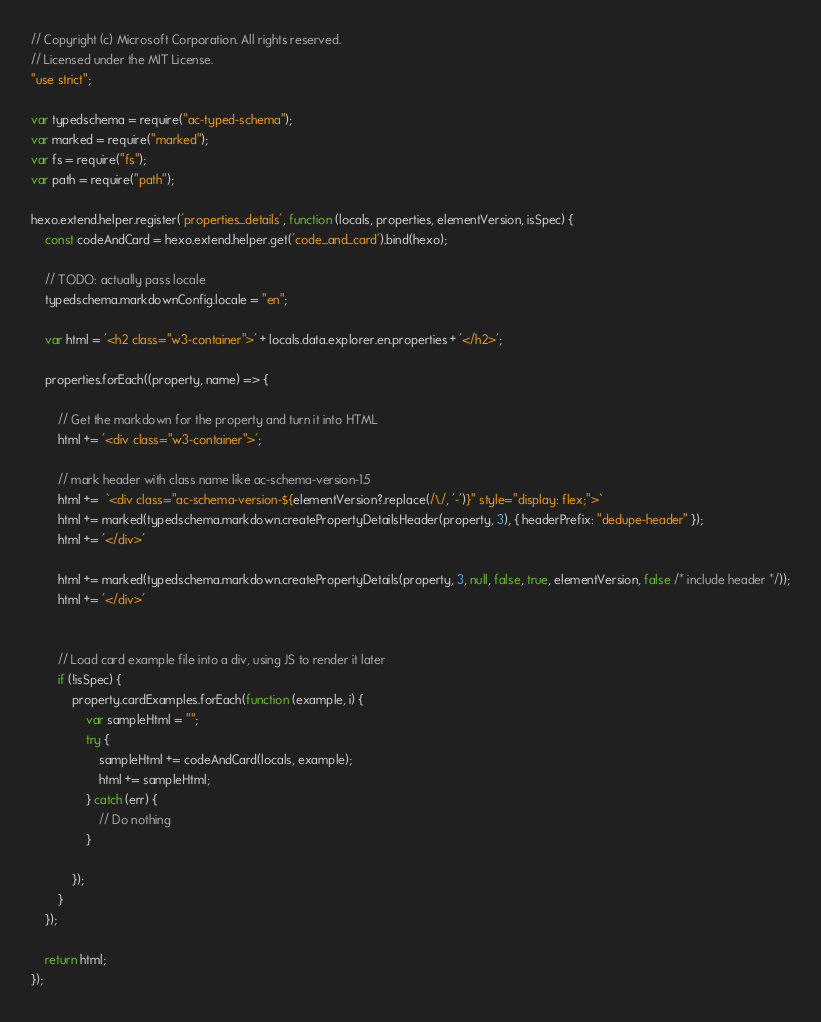Convert code to text. <code><loc_0><loc_0><loc_500><loc_500><_JavaScript_>// Copyright (c) Microsoft Corporation. All rights reserved.
// Licensed under the MIT License.
"use strict";

var typedschema = require("ac-typed-schema");
var marked = require("marked");
var fs = require("fs");
var path = require("path");

hexo.extend.helper.register('properties_details', function (locals, properties, elementVersion, isSpec) {
	const codeAndCard = hexo.extend.helper.get('code_and_card').bind(hexo);

    // TODO: actually pass locale
    typedschema.markdownConfig.locale = "en";

	var html = '<h2 class="w3-container">' + locals.data.explorer.en.properties + '</h2>';

	properties.forEach((property, name) => {

		// Get the markdown for the property and turn it into HTML
		html += '<div class="w3-container">';

		// mark header with class name like ac-schema-version-1.5
		html +=  `<div class="ac-schema-version-${elementVersion?.replace(/\./, '-')}" style="display: flex;">`
		html += marked(typedschema.markdown.createPropertyDetailsHeader(property, 3), { headerPrefix: "dedupe-header" });
		html += '</div>'

		html += marked(typedschema.markdown.createPropertyDetails(property, 3, null, false, true, elementVersion, false /* include header */));
		html += '</div>'


		// Load card example file into a div, using JS to render it later
		if (!isSpec) {
			property.cardExamples.forEach(function (example, i) {
				var sampleHtml = "";
				try {
					sampleHtml += codeAndCard(locals, example);
					html += sampleHtml;
				} catch (err) {
					// Do nothing
				}

			});
		}
	});

	return html;
});
</code> 